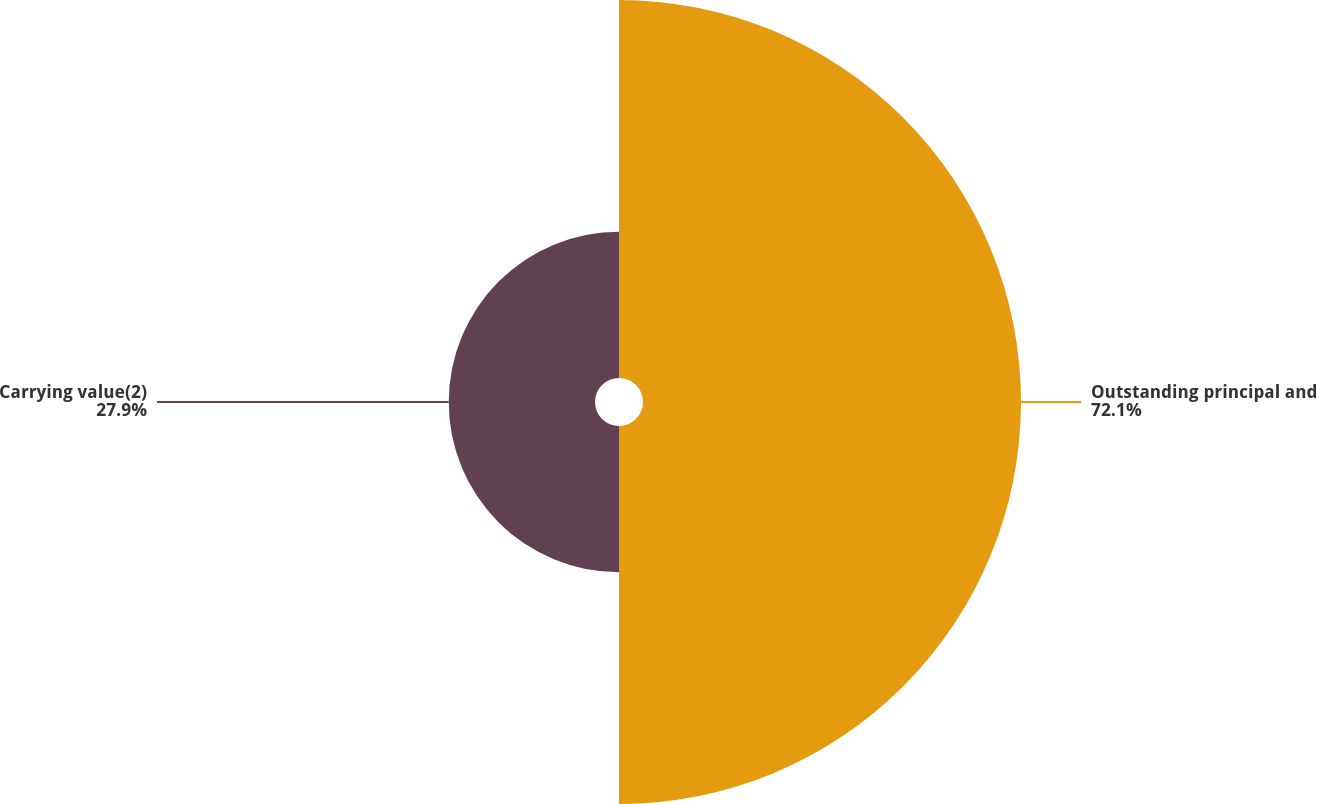<chart> <loc_0><loc_0><loc_500><loc_500><pie_chart><fcel>Outstanding principal and<fcel>Carrying value(2)<nl><fcel>72.1%<fcel>27.9%<nl></chart> 